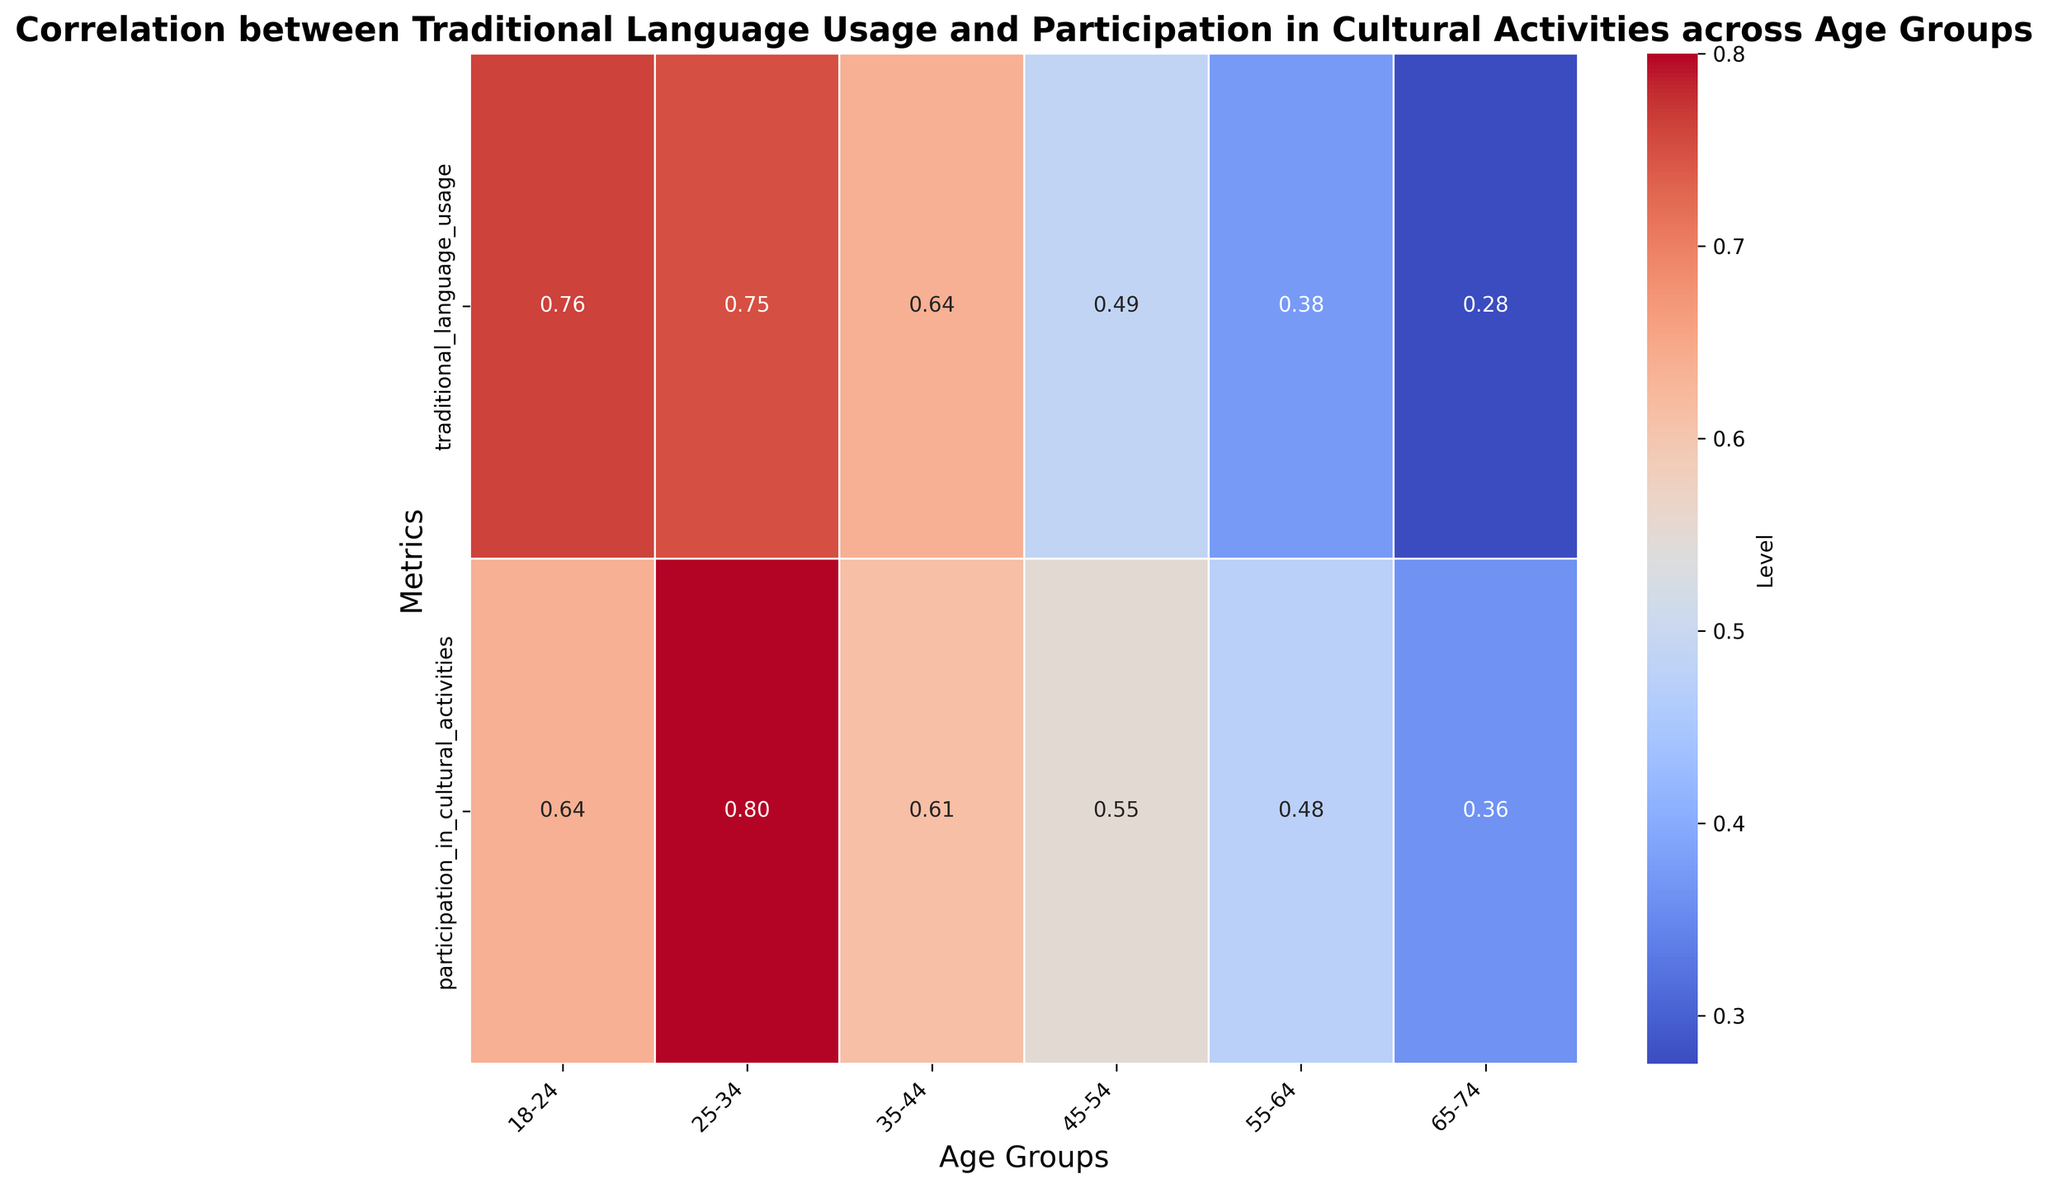What is the average traditional language usage in the 18-24 age group? The heatmap shows average values annotated. Look for the annotated value in the traditional language usage row under the 18-24 age group column. The value is 0.76.
Answer: 0.76 Which age group has the highest participation in cultural activities? Compare the annotated values in the participation in cultural activities row across all the age group columns. The highest value is under the 25-34 age group column, which is 0.80.
Answer: 25-34 Is the traditional language usage higher for the age group 35-44 or 45-54? Compare the annotated values in the traditional language usage row for the 35-44 and 45-54 age groups. The value for 35-44 is 0.64, while for 45-54, it is 0.49. 0.64 is greater than 0.49.
Answer: 35-44 Which metric (traditional language usage or participation in cultural activities) shows more variability across the age groups? Compare the range of values across all age groups for both rows. Traditional language usage ranges from 0.43 to 0.76, while participation in cultural activities ranges from 0.41 to 0.80. The range for participation in cultural activities (0.39) is slightly larger compared to traditional language usage (0.33).
Answer: participation in cultural activities Are there any age groups where the traditional language usage and participation in cultural activities are equal? Look for columns where the values are identical for both metrics. None of the age groups have equal values in traditional language usage and participation in cultural activities.
Answer: No Compare the traditional language usage of the 55-64 age group to the 65-74 age group. Which one has a lower value? Look at the annotated values in the traditional language usage row for both the 55-64 and 65-74 age groups. The value for 55-64 is 0.38, while for 65-74, it is 0.28. 0.28 is lower than 0.38.
Answer: 65-74 What is the difference in participation in cultural activities between the 25-34 and 45-54 age groups? Subtract the annotated value in the participation in cultural activities row for the 45-54 age group from that for the 25-34 age group. 0.80 - 0.55 = 0.25.
Answer: 0.25 